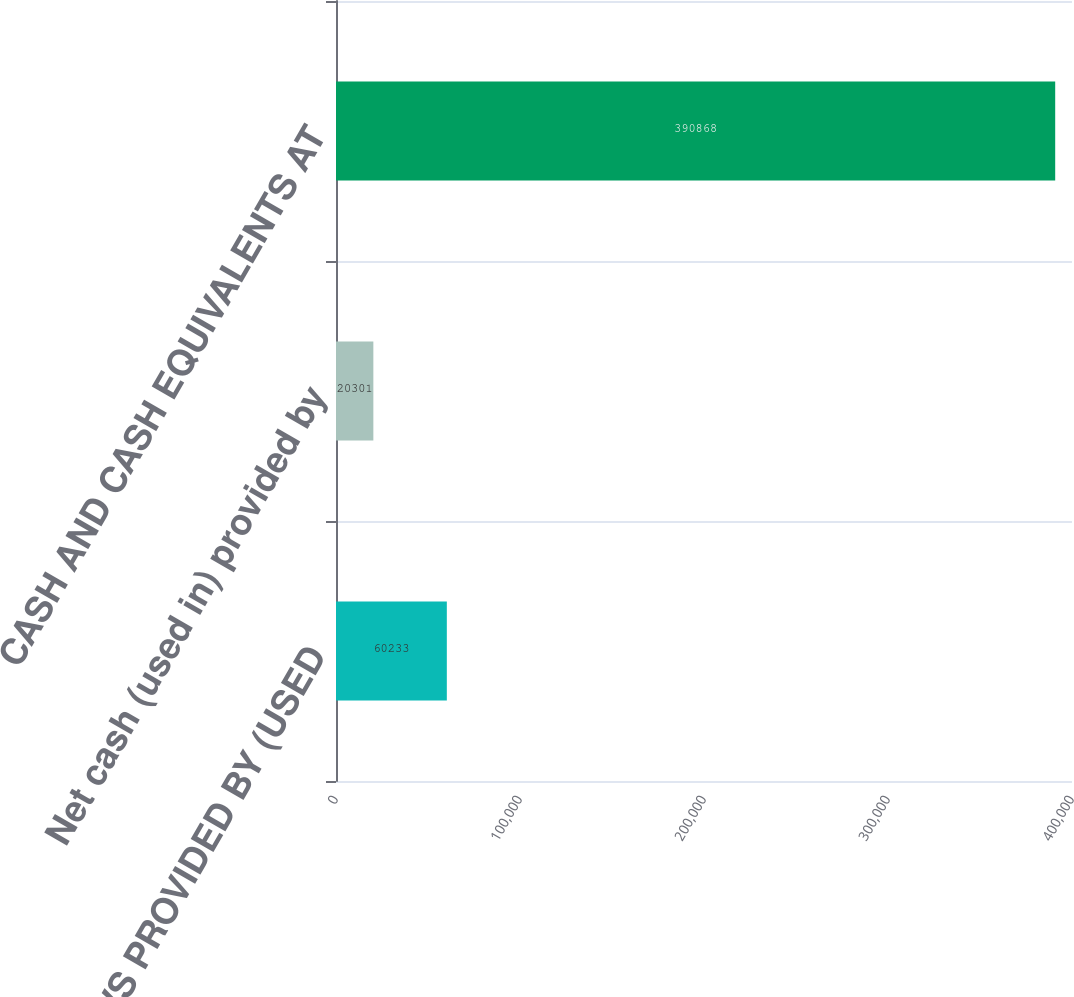Convert chart to OTSL. <chart><loc_0><loc_0><loc_500><loc_500><bar_chart><fcel>CASH FLOWS PROVIDED BY (USED<fcel>Net cash (used in) provided by<fcel>CASH AND CASH EQUIVALENTS AT<nl><fcel>60233<fcel>20301<fcel>390868<nl></chart> 